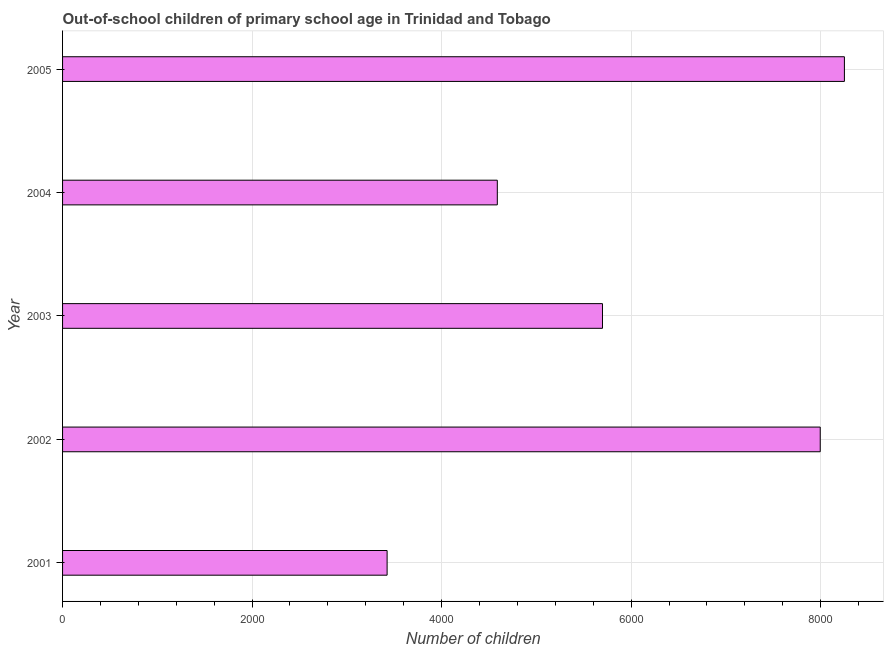Does the graph contain any zero values?
Offer a terse response. No. What is the title of the graph?
Ensure brevity in your answer.  Out-of-school children of primary school age in Trinidad and Tobago. What is the label or title of the X-axis?
Make the answer very short. Number of children. What is the number of out-of-school children in 2003?
Give a very brief answer. 5698. Across all years, what is the maximum number of out-of-school children?
Make the answer very short. 8251. Across all years, what is the minimum number of out-of-school children?
Offer a terse response. 3425. In which year was the number of out-of-school children minimum?
Provide a short and direct response. 2001. What is the sum of the number of out-of-school children?
Offer a terse response. 3.00e+04. What is the difference between the number of out-of-school children in 2004 and 2005?
Offer a terse response. -3663. What is the average number of out-of-school children per year?
Keep it short and to the point. 5991. What is the median number of out-of-school children?
Your answer should be compact. 5698. In how many years, is the number of out-of-school children greater than 7600 ?
Keep it short and to the point. 2. Do a majority of the years between 2002 and 2003 (inclusive) have number of out-of-school children greater than 800 ?
Make the answer very short. Yes. Is the difference between the number of out-of-school children in 2001 and 2004 greater than the difference between any two years?
Ensure brevity in your answer.  No. What is the difference between the highest and the second highest number of out-of-school children?
Keep it short and to the point. 255. Is the sum of the number of out-of-school children in 2001 and 2004 greater than the maximum number of out-of-school children across all years?
Your response must be concise. No. What is the difference between the highest and the lowest number of out-of-school children?
Ensure brevity in your answer.  4826. Are all the bars in the graph horizontal?
Make the answer very short. Yes. What is the Number of children of 2001?
Offer a terse response. 3425. What is the Number of children of 2002?
Ensure brevity in your answer.  7996. What is the Number of children of 2003?
Offer a terse response. 5698. What is the Number of children of 2004?
Your response must be concise. 4588. What is the Number of children of 2005?
Give a very brief answer. 8251. What is the difference between the Number of children in 2001 and 2002?
Your answer should be compact. -4571. What is the difference between the Number of children in 2001 and 2003?
Offer a very short reply. -2273. What is the difference between the Number of children in 2001 and 2004?
Offer a very short reply. -1163. What is the difference between the Number of children in 2001 and 2005?
Keep it short and to the point. -4826. What is the difference between the Number of children in 2002 and 2003?
Your response must be concise. 2298. What is the difference between the Number of children in 2002 and 2004?
Your answer should be very brief. 3408. What is the difference between the Number of children in 2002 and 2005?
Your response must be concise. -255. What is the difference between the Number of children in 2003 and 2004?
Your response must be concise. 1110. What is the difference between the Number of children in 2003 and 2005?
Your answer should be compact. -2553. What is the difference between the Number of children in 2004 and 2005?
Your response must be concise. -3663. What is the ratio of the Number of children in 2001 to that in 2002?
Offer a very short reply. 0.43. What is the ratio of the Number of children in 2001 to that in 2003?
Provide a succinct answer. 0.6. What is the ratio of the Number of children in 2001 to that in 2004?
Your answer should be very brief. 0.75. What is the ratio of the Number of children in 2001 to that in 2005?
Make the answer very short. 0.41. What is the ratio of the Number of children in 2002 to that in 2003?
Provide a succinct answer. 1.4. What is the ratio of the Number of children in 2002 to that in 2004?
Keep it short and to the point. 1.74. What is the ratio of the Number of children in 2002 to that in 2005?
Offer a terse response. 0.97. What is the ratio of the Number of children in 2003 to that in 2004?
Give a very brief answer. 1.24. What is the ratio of the Number of children in 2003 to that in 2005?
Provide a succinct answer. 0.69. What is the ratio of the Number of children in 2004 to that in 2005?
Provide a short and direct response. 0.56. 